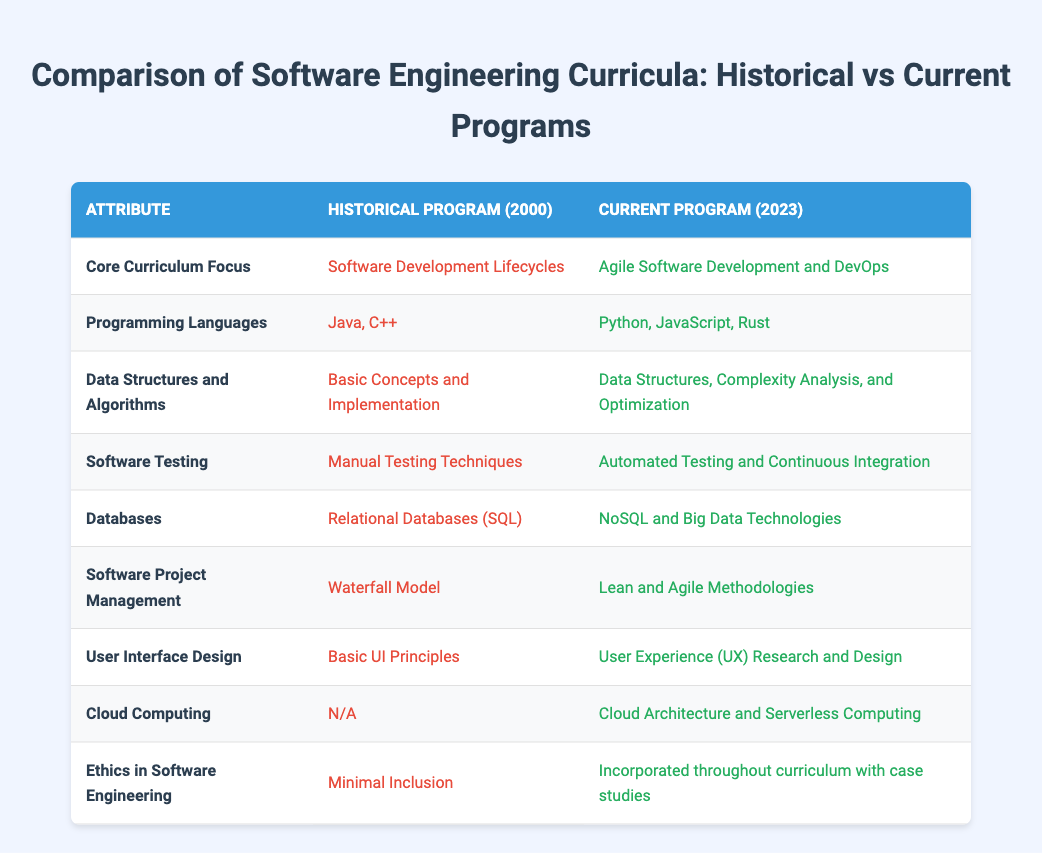What was the core curriculum focus in the historical program? The historical program focused on Software Development Lifecycles, as indicated in the table under the 'Core Curriculum Focus' attribute.
Answer: Software Development Lifecycles Which programming languages were included in the current program? The current program includes Python, JavaScript, and Rust, as specified in the 'Programming Languages' row of the table.
Answer: Python, JavaScript, Rust Is Cloud Computing included in the historical program? The historical program does not include Cloud Computing, as stated under the 'Cloud Computing' attribute where it mentions N/A.
Answer: No What is the difference in focus between Software Project Management in historical and current programs? The historical program emphasized the Waterfall Model, while the current program focuses on Lean and Agile Methodologies. This is a comparison of the two approaches to managing software projects as highlighted in the table.
Answer: Waterfall Model vs. Lean and Agile Methodologies How many programming languages are mentioned in the historical program versus the current program? The historical program mentions two programming languages: Java and C++, while the current program mentions three: Python, JavaScript, and Rust. Hence, the difference is one additional programming language in the current program, totaling three compared to two.
Answer: Current program has one more language Were automated testing techniques part of the historical software testing curriculum? No, the historical program focused on Manual Testing Techniques, which indicates that automated testing was not part of the curriculum as per the 'Software Testing' attribute.
Answer: No What logical change can be observed regarding the inclusion of Ethics in Software Engineering from 2000 to 2023? The inclusion of Ethics in Software Engineering has shifted from Minimal Inclusion in the historical program to being incorporated throughout the current curriculum with the use of case studies, indicating a significant enhancement in its educational emphasis over the years.
Answer: From minimal to comprehensive incorporation How many different types of database technologies are mentioned in both programs? The historical program mentions only Relational Databases (SQL), while the current program encompasses NoSQL and Big Data Technologies. Therefore, there is a total of three types being referenced across both programs.
Answer: Three types What can we infer about the trend in user interface design focus from the historical to current program? The historical program's focus on Basic UI Principles has evolved into a broader and more user-centered approach, emphasizing User Experience (UX) Research and Design in the current curriculum. This significant trend shows a shift towards prioritizing user needs and experiences.
Answer: Shift from basic UI to UX focus 